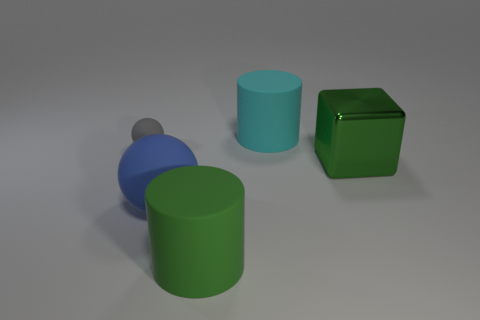Add 4 cyan rubber things. How many objects exist? 9 Subtract all spheres. How many objects are left? 3 Subtract all big gray metallic blocks. Subtract all green rubber objects. How many objects are left? 4 Add 5 blue objects. How many blue objects are left? 6 Add 3 green things. How many green things exist? 5 Subtract 0 red blocks. How many objects are left? 5 